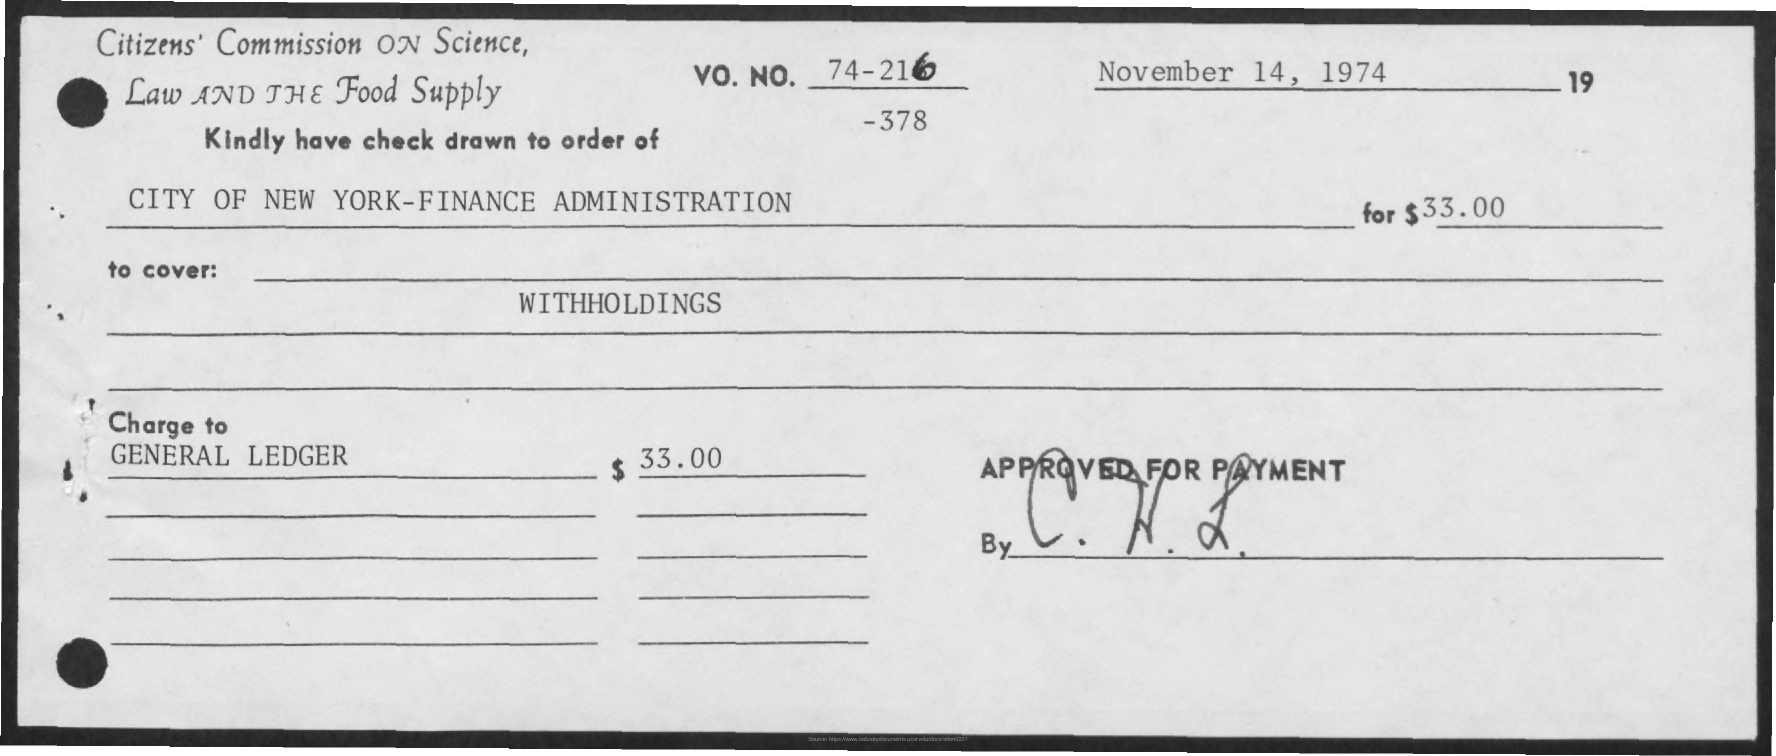What is the purpose of this cheque according to the document? The document suggests that the cheque is meant to cover 'WITHHOLDINGS' as it's noted in the purpose field, indicating it's likely for some form of withheld payment or deduction. 